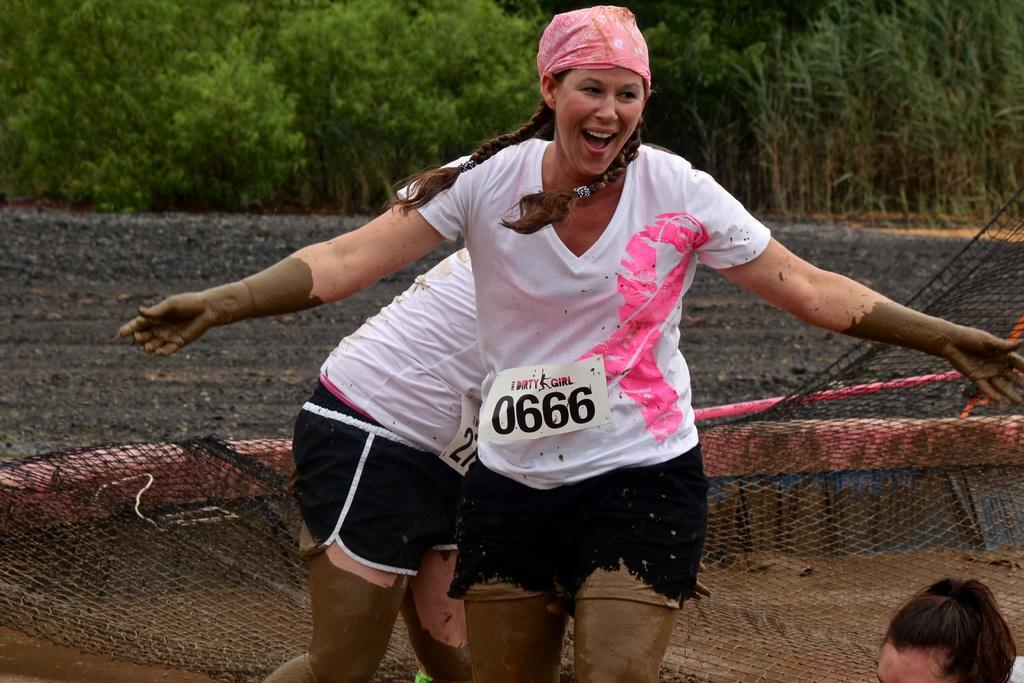<image>
Provide a brief description of the given image. a girl that has the number 0666 on it 